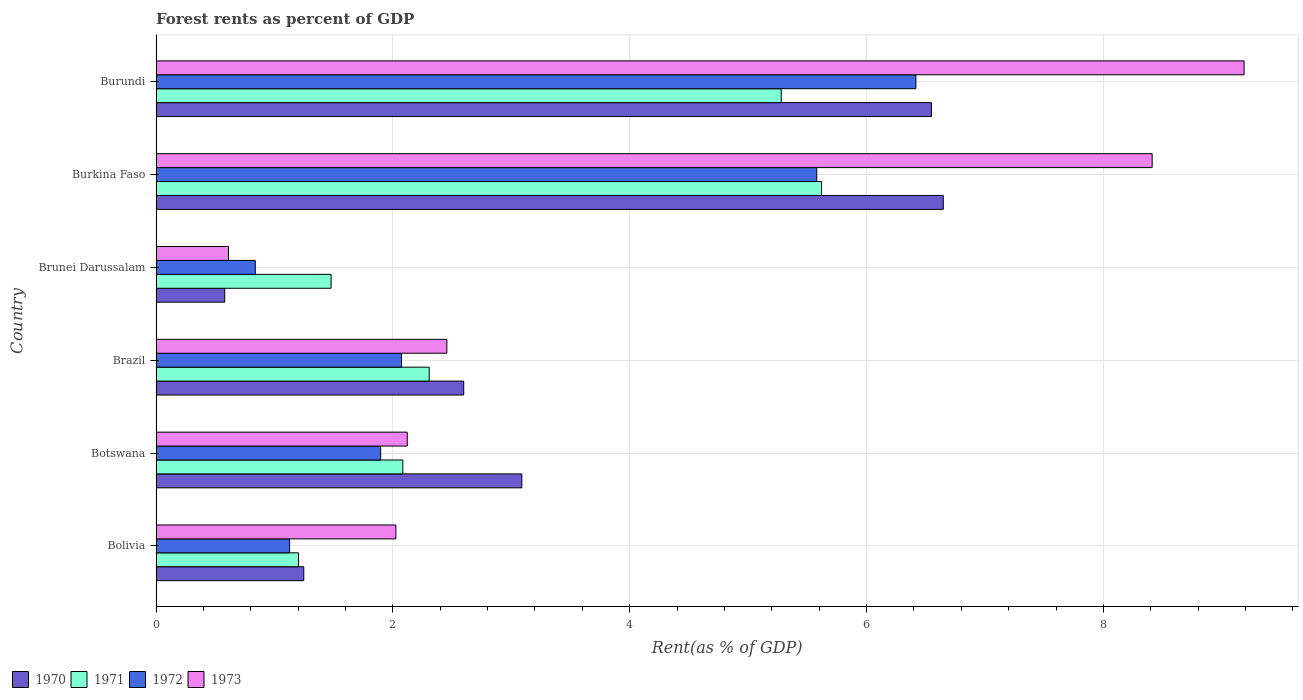Are the number of bars per tick equal to the number of legend labels?
Keep it short and to the point. Yes. How many bars are there on the 3rd tick from the top?
Provide a succinct answer. 4. How many bars are there on the 3rd tick from the bottom?
Ensure brevity in your answer.  4. What is the label of the 5th group of bars from the top?
Ensure brevity in your answer.  Botswana. What is the forest rent in 1970 in Brunei Darussalam?
Your answer should be compact. 0.58. Across all countries, what is the maximum forest rent in 1970?
Offer a very short reply. 6.65. Across all countries, what is the minimum forest rent in 1973?
Provide a short and direct response. 0.61. In which country was the forest rent in 1970 maximum?
Provide a short and direct response. Burkina Faso. What is the total forest rent in 1972 in the graph?
Offer a very short reply. 17.93. What is the difference between the forest rent in 1973 in Bolivia and that in Burkina Faso?
Provide a succinct answer. -6.39. What is the difference between the forest rent in 1973 in Brunei Darussalam and the forest rent in 1971 in Brazil?
Make the answer very short. -1.7. What is the average forest rent in 1970 per country?
Your answer should be very brief. 3.45. What is the difference between the forest rent in 1971 and forest rent in 1973 in Brazil?
Provide a succinct answer. -0.15. In how many countries, is the forest rent in 1971 greater than 2.4 %?
Give a very brief answer. 2. What is the ratio of the forest rent in 1973 in Botswana to that in Brunei Darussalam?
Offer a terse response. 3.47. What is the difference between the highest and the second highest forest rent in 1971?
Your answer should be very brief. 0.34. What is the difference between the highest and the lowest forest rent in 1972?
Keep it short and to the point. 5.58. Is the sum of the forest rent in 1971 in Burkina Faso and Burundi greater than the maximum forest rent in 1970 across all countries?
Provide a short and direct response. Yes. What does the 3rd bar from the bottom in Botswana represents?
Offer a very short reply. 1972. How many bars are there?
Provide a succinct answer. 24. Are all the bars in the graph horizontal?
Your answer should be compact. Yes. How many countries are there in the graph?
Ensure brevity in your answer.  6. Are the values on the major ticks of X-axis written in scientific E-notation?
Give a very brief answer. No. Does the graph contain any zero values?
Provide a succinct answer. No. Does the graph contain grids?
Provide a succinct answer. Yes. How are the legend labels stacked?
Give a very brief answer. Horizontal. What is the title of the graph?
Keep it short and to the point. Forest rents as percent of GDP. What is the label or title of the X-axis?
Make the answer very short. Rent(as % of GDP). What is the Rent(as % of GDP) of 1970 in Bolivia?
Your answer should be very brief. 1.25. What is the Rent(as % of GDP) of 1971 in Bolivia?
Make the answer very short. 1.2. What is the Rent(as % of GDP) of 1972 in Bolivia?
Provide a short and direct response. 1.13. What is the Rent(as % of GDP) of 1973 in Bolivia?
Offer a very short reply. 2.03. What is the Rent(as % of GDP) in 1970 in Botswana?
Keep it short and to the point. 3.09. What is the Rent(as % of GDP) of 1971 in Botswana?
Make the answer very short. 2.08. What is the Rent(as % of GDP) in 1972 in Botswana?
Provide a short and direct response. 1.9. What is the Rent(as % of GDP) of 1973 in Botswana?
Your answer should be compact. 2.12. What is the Rent(as % of GDP) of 1970 in Brazil?
Ensure brevity in your answer.  2.6. What is the Rent(as % of GDP) in 1971 in Brazil?
Your answer should be compact. 2.31. What is the Rent(as % of GDP) in 1972 in Brazil?
Give a very brief answer. 2.07. What is the Rent(as % of GDP) of 1973 in Brazil?
Give a very brief answer. 2.46. What is the Rent(as % of GDP) in 1970 in Brunei Darussalam?
Your answer should be very brief. 0.58. What is the Rent(as % of GDP) in 1971 in Brunei Darussalam?
Your answer should be compact. 1.48. What is the Rent(as % of GDP) of 1972 in Brunei Darussalam?
Ensure brevity in your answer.  0.84. What is the Rent(as % of GDP) in 1973 in Brunei Darussalam?
Make the answer very short. 0.61. What is the Rent(as % of GDP) in 1970 in Burkina Faso?
Ensure brevity in your answer.  6.65. What is the Rent(as % of GDP) of 1971 in Burkina Faso?
Your answer should be compact. 5.62. What is the Rent(as % of GDP) in 1972 in Burkina Faso?
Keep it short and to the point. 5.58. What is the Rent(as % of GDP) in 1973 in Burkina Faso?
Provide a succinct answer. 8.41. What is the Rent(as % of GDP) in 1970 in Burundi?
Your answer should be compact. 6.55. What is the Rent(as % of GDP) of 1971 in Burundi?
Offer a very short reply. 5.28. What is the Rent(as % of GDP) in 1972 in Burundi?
Ensure brevity in your answer.  6.42. What is the Rent(as % of GDP) in 1973 in Burundi?
Keep it short and to the point. 9.19. Across all countries, what is the maximum Rent(as % of GDP) in 1970?
Ensure brevity in your answer.  6.65. Across all countries, what is the maximum Rent(as % of GDP) of 1971?
Keep it short and to the point. 5.62. Across all countries, what is the maximum Rent(as % of GDP) of 1972?
Ensure brevity in your answer.  6.42. Across all countries, what is the maximum Rent(as % of GDP) in 1973?
Your answer should be compact. 9.19. Across all countries, what is the minimum Rent(as % of GDP) of 1970?
Your answer should be very brief. 0.58. Across all countries, what is the minimum Rent(as % of GDP) in 1971?
Ensure brevity in your answer.  1.2. Across all countries, what is the minimum Rent(as % of GDP) in 1972?
Provide a short and direct response. 0.84. Across all countries, what is the minimum Rent(as % of GDP) of 1973?
Keep it short and to the point. 0.61. What is the total Rent(as % of GDP) in 1970 in the graph?
Keep it short and to the point. 20.71. What is the total Rent(as % of GDP) in 1971 in the graph?
Give a very brief answer. 17.97. What is the total Rent(as % of GDP) in 1972 in the graph?
Provide a succinct answer. 17.93. What is the total Rent(as % of GDP) in 1973 in the graph?
Give a very brief answer. 24.81. What is the difference between the Rent(as % of GDP) of 1970 in Bolivia and that in Botswana?
Your answer should be very brief. -1.84. What is the difference between the Rent(as % of GDP) in 1971 in Bolivia and that in Botswana?
Give a very brief answer. -0.88. What is the difference between the Rent(as % of GDP) of 1972 in Bolivia and that in Botswana?
Make the answer very short. -0.77. What is the difference between the Rent(as % of GDP) in 1973 in Bolivia and that in Botswana?
Provide a short and direct response. -0.1. What is the difference between the Rent(as % of GDP) of 1970 in Bolivia and that in Brazil?
Ensure brevity in your answer.  -1.35. What is the difference between the Rent(as % of GDP) of 1971 in Bolivia and that in Brazil?
Provide a short and direct response. -1.1. What is the difference between the Rent(as % of GDP) in 1972 in Bolivia and that in Brazil?
Offer a terse response. -0.95. What is the difference between the Rent(as % of GDP) of 1973 in Bolivia and that in Brazil?
Provide a succinct answer. -0.43. What is the difference between the Rent(as % of GDP) in 1970 in Bolivia and that in Brunei Darussalam?
Provide a short and direct response. 0.67. What is the difference between the Rent(as % of GDP) in 1971 in Bolivia and that in Brunei Darussalam?
Your answer should be compact. -0.28. What is the difference between the Rent(as % of GDP) in 1972 in Bolivia and that in Brunei Darussalam?
Your answer should be very brief. 0.29. What is the difference between the Rent(as % of GDP) in 1973 in Bolivia and that in Brunei Darussalam?
Offer a terse response. 1.41. What is the difference between the Rent(as % of GDP) of 1970 in Bolivia and that in Burkina Faso?
Provide a short and direct response. -5.4. What is the difference between the Rent(as % of GDP) of 1971 in Bolivia and that in Burkina Faso?
Your response must be concise. -4.42. What is the difference between the Rent(as % of GDP) of 1972 in Bolivia and that in Burkina Faso?
Give a very brief answer. -4.45. What is the difference between the Rent(as % of GDP) of 1973 in Bolivia and that in Burkina Faso?
Provide a succinct answer. -6.39. What is the difference between the Rent(as % of GDP) in 1970 in Bolivia and that in Burundi?
Give a very brief answer. -5.3. What is the difference between the Rent(as % of GDP) in 1971 in Bolivia and that in Burundi?
Offer a terse response. -4.08. What is the difference between the Rent(as % of GDP) of 1972 in Bolivia and that in Burundi?
Your answer should be compact. -5.29. What is the difference between the Rent(as % of GDP) of 1973 in Bolivia and that in Burundi?
Offer a terse response. -7.16. What is the difference between the Rent(as % of GDP) of 1970 in Botswana and that in Brazil?
Offer a terse response. 0.49. What is the difference between the Rent(as % of GDP) of 1971 in Botswana and that in Brazil?
Ensure brevity in your answer.  -0.22. What is the difference between the Rent(as % of GDP) of 1972 in Botswana and that in Brazil?
Provide a short and direct response. -0.18. What is the difference between the Rent(as % of GDP) in 1973 in Botswana and that in Brazil?
Ensure brevity in your answer.  -0.33. What is the difference between the Rent(as % of GDP) in 1970 in Botswana and that in Brunei Darussalam?
Your response must be concise. 2.51. What is the difference between the Rent(as % of GDP) of 1971 in Botswana and that in Brunei Darussalam?
Your answer should be compact. 0.61. What is the difference between the Rent(as % of GDP) of 1972 in Botswana and that in Brunei Darussalam?
Give a very brief answer. 1.06. What is the difference between the Rent(as % of GDP) of 1973 in Botswana and that in Brunei Darussalam?
Ensure brevity in your answer.  1.51. What is the difference between the Rent(as % of GDP) of 1970 in Botswana and that in Burkina Faso?
Your answer should be very brief. -3.56. What is the difference between the Rent(as % of GDP) in 1971 in Botswana and that in Burkina Faso?
Ensure brevity in your answer.  -3.54. What is the difference between the Rent(as % of GDP) in 1972 in Botswana and that in Burkina Faso?
Offer a very short reply. -3.68. What is the difference between the Rent(as % of GDP) in 1973 in Botswana and that in Burkina Faso?
Keep it short and to the point. -6.29. What is the difference between the Rent(as % of GDP) of 1970 in Botswana and that in Burundi?
Keep it short and to the point. -3.46. What is the difference between the Rent(as % of GDP) of 1971 in Botswana and that in Burundi?
Your response must be concise. -3.2. What is the difference between the Rent(as % of GDP) in 1972 in Botswana and that in Burundi?
Provide a short and direct response. -4.52. What is the difference between the Rent(as % of GDP) of 1973 in Botswana and that in Burundi?
Make the answer very short. -7.07. What is the difference between the Rent(as % of GDP) in 1970 in Brazil and that in Brunei Darussalam?
Keep it short and to the point. 2.02. What is the difference between the Rent(as % of GDP) of 1971 in Brazil and that in Brunei Darussalam?
Offer a terse response. 0.83. What is the difference between the Rent(as % of GDP) of 1972 in Brazil and that in Brunei Darussalam?
Your answer should be very brief. 1.24. What is the difference between the Rent(as % of GDP) of 1973 in Brazil and that in Brunei Darussalam?
Your answer should be very brief. 1.84. What is the difference between the Rent(as % of GDP) of 1970 in Brazil and that in Burkina Faso?
Offer a very short reply. -4.05. What is the difference between the Rent(as % of GDP) of 1971 in Brazil and that in Burkina Faso?
Ensure brevity in your answer.  -3.31. What is the difference between the Rent(as % of GDP) in 1972 in Brazil and that in Burkina Faso?
Provide a short and direct response. -3.51. What is the difference between the Rent(as % of GDP) in 1973 in Brazil and that in Burkina Faso?
Provide a short and direct response. -5.96. What is the difference between the Rent(as % of GDP) of 1970 in Brazil and that in Burundi?
Provide a succinct answer. -3.95. What is the difference between the Rent(as % of GDP) of 1971 in Brazil and that in Burundi?
Provide a succinct answer. -2.97. What is the difference between the Rent(as % of GDP) in 1972 in Brazil and that in Burundi?
Offer a terse response. -4.34. What is the difference between the Rent(as % of GDP) of 1973 in Brazil and that in Burundi?
Your answer should be compact. -6.73. What is the difference between the Rent(as % of GDP) in 1970 in Brunei Darussalam and that in Burkina Faso?
Your answer should be very brief. -6.07. What is the difference between the Rent(as % of GDP) in 1971 in Brunei Darussalam and that in Burkina Faso?
Make the answer very short. -4.14. What is the difference between the Rent(as % of GDP) in 1972 in Brunei Darussalam and that in Burkina Faso?
Offer a very short reply. -4.74. What is the difference between the Rent(as % of GDP) in 1973 in Brunei Darussalam and that in Burkina Faso?
Your answer should be very brief. -7.8. What is the difference between the Rent(as % of GDP) in 1970 in Brunei Darussalam and that in Burundi?
Ensure brevity in your answer.  -5.97. What is the difference between the Rent(as % of GDP) in 1971 in Brunei Darussalam and that in Burundi?
Provide a short and direct response. -3.8. What is the difference between the Rent(as % of GDP) of 1972 in Brunei Darussalam and that in Burundi?
Your answer should be compact. -5.58. What is the difference between the Rent(as % of GDP) of 1973 in Brunei Darussalam and that in Burundi?
Make the answer very short. -8.58. What is the difference between the Rent(as % of GDP) of 1970 in Burkina Faso and that in Burundi?
Provide a short and direct response. 0.1. What is the difference between the Rent(as % of GDP) in 1971 in Burkina Faso and that in Burundi?
Your answer should be compact. 0.34. What is the difference between the Rent(as % of GDP) in 1972 in Burkina Faso and that in Burundi?
Offer a terse response. -0.84. What is the difference between the Rent(as % of GDP) of 1973 in Burkina Faso and that in Burundi?
Give a very brief answer. -0.78. What is the difference between the Rent(as % of GDP) of 1970 in Bolivia and the Rent(as % of GDP) of 1971 in Botswana?
Your answer should be compact. -0.84. What is the difference between the Rent(as % of GDP) of 1970 in Bolivia and the Rent(as % of GDP) of 1972 in Botswana?
Provide a succinct answer. -0.65. What is the difference between the Rent(as % of GDP) of 1970 in Bolivia and the Rent(as % of GDP) of 1973 in Botswana?
Make the answer very short. -0.87. What is the difference between the Rent(as % of GDP) in 1971 in Bolivia and the Rent(as % of GDP) in 1972 in Botswana?
Make the answer very short. -0.69. What is the difference between the Rent(as % of GDP) in 1971 in Bolivia and the Rent(as % of GDP) in 1973 in Botswana?
Your answer should be very brief. -0.92. What is the difference between the Rent(as % of GDP) in 1972 in Bolivia and the Rent(as % of GDP) in 1973 in Botswana?
Provide a short and direct response. -0.99. What is the difference between the Rent(as % of GDP) of 1970 in Bolivia and the Rent(as % of GDP) of 1971 in Brazil?
Give a very brief answer. -1.06. What is the difference between the Rent(as % of GDP) of 1970 in Bolivia and the Rent(as % of GDP) of 1972 in Brazil?
Give a very brief answer. -0.83. What is the difference between the Rent(as % of GDP) in 1970 in Bolivia and the Rent(as % of GDP) in 1973 in Brazil?
Ensure brevity in your answer.  -1.21. What is the difference between the Rent(as % of GDP) of 1971 in Bolivia and the Rent(as % of GDP) of 1972 in Brazil?
Keep it short and to the point. -0.87. What is the difference between the Rent(as % of GDP) of 1971 in Bolivia and the Rent(as % of GDP) of 1973 in Brazil?
Offer a very short reply. -1.25. What is the difference between the Rent(as % of GDP) in 1972 in Bolivia and the Rent(as % of GDP) in 1973 in Brazil?
Offer a very short reply. -1.33. What is the difference between the Rent(as % of GDP) of 1970 in Bolivia and the Rent(as % of GDP) of 1971 in Brunei Darussalam?
Make the answer very short. -0.23. What is the difference between the Rent(as % of GDP) of 1970 in Bolivia and the Rent(as % of GDP) of 1972 in Brunei Darussalam?
Offer a very short reply. 0.41. What is the difference between the Rent(as % of GDP) in 1970 in Bolivia and the Rent(as % of GDP) in 1973 in Brunei Darussalam?
Your answer should be very brief. 0.64. What is the difference between the Rent(as % of GDP) in 1971 in Bolivia and the Rent(as % of GDP) in 1972 in Brunei Darussalam?
Keep it short and to the point. 0.36. What is the difference between the Rent(as % of GDP) in 1971 in Bolivia and the Rent(as % of GDP) in 1973 in Brunei Darussalam?
Ensure brevity in your answer.  0.59. What is the difference between the Rent(as % of GDP) in 1972 in Bolivia and the Rent(as % of GDP) in 1973 in Brunei Darussalam?
Provide a succinct answer. 0.52. What is the difference between the Rent(as % of GDP) of 1970 in Bolivia and the Rent(as % of GDP) of 1971 in Burkina Faso?
Give a very brief answer. -4.37. What is the difference between the Rent(as % of GDP) of 1970 in Bolivia and the Rent(as % of GDP) of 1972 in Burkina Faso?
Provide a succinct answer. -4.33. What is the difference between the Rent(as % of GDP) in 1970 in Bolivia and the Rent(as % of GDP) in 1973 in Burkina Faso?
Your answer should be very brief. -7.16. What is the difference between the Rent(as % of GDP) in 1971 in Bolivia and the Rent(as % of GDP) in 1972 in Burkina Faso?
Keep it short and to the point. -4.38. What is the difference between the Rent(as % of GDP) of 1971 in Bolivia and the Rent(as % of GDP) of 1973 in Burkina Faso?
Your answer should be very brief. -7.21. What is the difference between the Rent(as % of GDP) of 1972 in Bolivia and the Rent(as % of GDP) of 1973 in Burkina Faso?
Provide a succinct answer. -7.28. What is the difference between the Rent(as % of GDP) of 1970 in Bolivia and the Rent(as % of GDP) of 1971 in Burundi?
Your response must be concise. -4.03. What is the difference between the Rent(as % of GDP) in 1970 in Bolivia and the Rent(as % of GDP) in 1972 in Burundi?
Ensure brevity in your answer.  -5.17. What is the difference between the Rent(as % of GDP) in 1970 in Bolivia and the Rent(as % of GDP) in 1973 in Burundi?
Provide a short and direct response. -7.94. What is the difference between the Rent(as % of GDP) in 1971 in Bolivia and the Rent(as % of GDP) in 1972 in Burundi?
Offer a terse response. -5.21. What is the difference between the Rent(as % of GDP) in 1971 in Bolivia and the Rent(as % of GDP) in 1973 in Burundi?
Keep it short and to the point. -7.99. What is the difference between the Rent(as % of GDP) of 1972 in Bolivia and the Rent(as % of GDP) of 1973 in Burundi?
Your answer should be compact. -8.06. What is the difference between the Rent(as % of GDP) in 1970 in Botswana and the Rent(as % of GDP) in 1971 in Brazil?
Provide a succinct answer. 0.78. What is the difference between the Rent(as % of GDP) in 1970 in Botswana and the Rent(as % of GDP) in 1972 in Brazil?
Make the answer very short. 1.02. What is the difference between the Rent(as % of GDP) of 1970 in Botswana and the Rent(as % of GDP) of 1973 in Brazil?
Your answer should be very brief. 0.63. What is the difference between the Rent(as % of GDP) in 1971 in Botswana and the Rent(as % of GDP) in 1972 in Brazil?
Offer a very short reply. 0.01. What is the difference between the Rent(as % of GDP) of 1971 in Botswana and the Rent(as % of GDP) of 1973 in Brazil?
Your response must be concise. -0.37. What is the difference between the Rent(as % of GDP) in 1972 in Botswana and the Rent(as % of GDP) in 1973 in Brazil?
Offer a very short reply. -0.56. What is the difference between the Rent(as % of GDP) in 1970 in Botswana and the Rent(as % of GDP) in 1971 in Brunei Darussalam?
Offer a very short reply. 1.61. What is the difference between the Rent(as % of GDP) of 1970 in Botswana and the Rent(as % of GDP) of 1972 in Brunei Darussalam?
Give a very brief answer. 2.25. What is the difference between the Rent(as % of GDP) in 1970 in Botswana and the Rent(as % of GDP) in 1973 in Brunei Darussalam?
Ensure brevity in your answer.  2.48. What is the difference between the Rent(as % of GDP) of 1971 in Botswana and the Rent(as % of GDP) of 1972 in Brunei Darussalam?
Provide a succinct answer. 1.25. What is the difference between the Rent(as % of GDP) in 1971 in Botswana and the Rent(as % of GDP) in 1973 in Brunei Darussalam?
Offer a terse response. 1.47. What is the difference between the Rent(as % of GDP) in 1972 in Botswana and the Rent(as % of GDP) in 1973 in Brunei Darussalam?
Your answer should be very brief. 1.29. What is the difference between the Rent(as % of GDP) of 1970 in Botswana and the Rent(as % of GDP) of 1971 in Burkina Faso?
Provide a succinct answer. -2.53. What is the difference between the Rent(as % of GDP) in 1970 in Botswana and the Rent(as % of GDP) in 1972 in Burkina Faso?
Provide a short and direct response. -2.49. What is the difference between the Rent(as % of GDP) in 1970 in Botswana and the Rent(as % of GDP) in 1973 in Burkina Faso?
Ensure brevity in your answer.  -5.32. What is the difference between the Rent(as % of GDP) of 1971 in Botswana and the Rent(as % of GDP) of 1972 in Burkina Faso?
Your answer should be compact. -3.5. What is the difference between the Rent(as % of GDP) in 1971 in Botswana and the Rent(as % of GDP) in 1973 in Burkina Faso?
Ensure brevity in your answer.  -6.33. What is the difference between the Rent(as % of GDP) in 1972 in Botswana and the Rent(as % of GDP) in 1973 in Burkina Faso?
Your answer should be very brief. -6.51. What is the difference between the Rent(as % of GDP) in 1970 in Botswana and the Rent(as % of GDP) in 1971 in Burundi?
Ensure brevity in your answer.  -2.19. What is the difference between the Rent(as % of GDP) of 1970 in Botswana and the Rent(as % of GDP) of 1972 in Burundi?
Offer a terse response. -3.33. What is the difference between the Rent(as % of GDP) in 1970 in Botswana and the Rent(as % of GDP) in 1973 in Burundi?
Offer a terse response. -6.1. What is the difference between the Rent(as % of GDP) in 1971 in Botswana and the Rent(as % of GDP) in 1972 in Burundi?
Ensure brevity in your answer.  -4.33. What is the difference between the Rent(as % of GDP) of 1971 in Botswana and the Rent(as % of GDP) of 1973 in Burundi?
Your answer should be compact. -7.1. What is the difference between the Rent(as % of GDP) in 1972 in Botswana and the Rent(as % of GDP) in 1973 in Burundi?
Your answer should be very brief. -7.29. What is the difference between the Rent(as % of GDP) of 1970 in Brazil and the Rent(as % of GDP) of 1971 in Brunei Darussalam?
Offer a terse response. 1.12. What is the difference between the Rent(as % of GDP) in 1970 in Brazil and the Rent(as % of GDP) in 1972 in Brunei Darussalam?
Make the answer very short. 1.76. What is the difference between the Rent(as % of GDP) in 1970 in Brazil and the Rent(as % of GDP) in 1973 in Brunei Darussalam?
Keep it short and to the point. 1.99. What is the difference between the Rent(as % of GDP) in 1971 in Brazil and the Rent(as % of GDP) in 1972 in Brunei Darussalam?
Your response must be concise. 1.47. What is the difference between the Rent(as % of GDP) of 1971 in Brazil and the Rent(as % of GDP) of 1973 in Brunei Darussalam?
Your response must be concise. 1.7. What is the difference between the Rent(as % of GDP) of 1972 in Brazil and the Rent(as % of GDP) of 1973 in Brunei Darussalam?
Your response must be concise. 1.46. What is the difference between the Rent(as % of GDP) in 1970 in Brazil and the Rent(as % of GDP) in 1971 in Burkina Faso?
Your response must be concise. -3.02. What is the difference between the Rent(as % of GDP) in 1970 in Brazil and the Rent(as % of GDP) in 1972 in Burkina Faso?
Your response must be concise. -2.98. What is the difference between the Rent(as % of GDP) of 1970 in Brazil and the Rent(as % of GDP) of 1973 in Burkina Faso?
Give a very brief answer. -5.81. What is the difference between the Rent(as % of GDP) of 1971 in Brazil and the Rent(as % of GDP) of 1972 in Burkina Faso?
Ensure brevity in your answer.  -3.27. What is the difference between the Rent(as % of GDP) of 1971 in Brazil and the Rent(as % of GDP) of 1973 in Burkina Faso?
Your answer should be compact. -6.11. What is the difference between the Rent(as % of GDP) of 1972 in Brazil and the Rent(as % of GDP) of 1973 in Burkina Faso?
Your answer should be very brief. -6.34. What is the difference between the Rent(as % of GDP) in 1970 in Brazil and the Rent(as % of GDP) in 1971 in Burundi?
Give a very brief answer. -2.68. What is the difference between the Rent(as % of GDP) of 1970 in Brazil and the Rent(as % of GDP) of 1972 in Burundi?
Give a very brief answer. -3.82. What is the difference between the Rent(as % of GDP) of 1970 in Brazil and the Rent(as % of GDP) of 1973 in Burundi?
Give a very brief answer. -6.59. What is the difference between the Rent(as % of GDP) of 1971 in Brazil and the Rent(as % of GDP) of 1972 in Burundi?
Offer a very short reply. -4.11. What is the difference between the Rent(as % of GDP) of 1971 in Brazil and the Rent(as % of GDP) of 1973 in Burundi?
Provide a short and direct response. -6.88. What is the difference between the Rent(as % of GDP) in 1972 in Brazil and the Rent(as % of GDP) in 1973 in Burundi?
Keep it short and to the point. -7.11. What is the difference between the Rent(as % of GDP) of 1970 in Brunei Darussalam and the Rent(as % of GDP) of 1971 in Burkina Faso?
Give a very brief answer. -5.04. What is the difference between the Rent(as % of GDP) in 1970 in Brunei Darussalam and the Rent(as % of GDP) in 1972 in Burkina Faso?
Keep it short and to the point. -5. What is the difference between the Rent(as % of GDP) in 1970 in Brunei Darussalam and the Rent(as % of GDP) in 1973 in Burkina Faso?
Offer a very short reply. -7.83. What is the difference between the Rent(as % of GDP) in 1971 in Brunei Darussalam and the Rent(as % of GDP) in 1972 in Burkina Faso?
Ensure brevity in your answer.  -4.1. What is the difference between the Rent(as % of GDP) in 1971 in Brunei Darussalam and the Rent(as % of GDP) in 1973 in Burkina Faso?
Your response must be concise. -6.93. What is the difference between the Rent(as % of GDP) in 1972 in Brunei Darussalam and the Rent(as % of GDP) in 1973 in Burkina Faso?
Offer a terse response. -7.57. What is the difference between the Rent(as % of GDP) in 1970 in Brunei Darussalam and the Rent(as % of GDP) in 1971 in Burundi?
Your answer should be compact. -4.7. What is the difference between the Rent(as % of GDP) in 1970 in Brunei Darussalam and the Rent(as % of GDP) in 1972 in Burundi?
Offer a very short reply. -5.84. What is the difference between the Rent(as % of GDP) of 1970 in Brunei Darussalam and the Rent(as % of GDP) of 1973 in Burundi?
Your response must be concise. -8.61. What is the difference between the Rent(as % of GDP) of 1971 in Brunei Darussalam and the Rent(as % of GDP) of 1972 in Burundi?
Offer a very short reply. -4.94. What is the difference between the Rent(as % of GDP) of 1971 in Brunei Darussalam and the Rent(as % of GDP) of 1973 in Burundi?
Provide a short and direct response. -7.71. What is the difference between the Rent(as % of GDP) of 1972 in Brunei Darussalam and the Rent(as % of GDP) of 1973 in Burundi?
Keep it short and to the point. -8.35. What is the difference between the Rent(as % of GDP) in 1970 in Burkina Faso and the Rent(as % of GDP) in 1971 in Burundi?
Make the answer very short. 1.37. What is the difference between the Rent(as % of GDP) in 1970 in Burkina Faso and the Rent(as % of GDP) in 1972 in Burundi?
Offer a terse response. 0.23. What is the difference between the Rent(as % of GDP) of 1970 in Burkina Faso and the Rent(as % of GDP) of 1973 in Burundi?
Your response must be concise. -2.54. What is the difference between the Rent(as % of GDP) of 1971 in Burkina Faso and the Rent(as % of GDP) of 1972 in Burundi?
Make the answer very short. -0.8. What is the difference between the Rent(as % of GDP) of 1971 in Burkina Faso and the Rent(as % of GDP) of 1973 in Burundi?
Keep it short and to the point. -3.57. What is the difference between the Rent(as % of GDP) of 1972 in Burkina Faso and the Rent(as % of GDP) of 1973 in Burundi?
Give a very brief answer. -3.61. What is the average Rent(as % of GDP) of 1970 per country?
Give a very brief answer. 3.45. What is the average Rent(as % of GDP) of 1971 per country?
Offer a terse response. 3. What is the average Rent(as % of GDP) in 1972 per country?
Keep it short and to the point. 2.99. What is the average Rent(as % of GDP) in 1973 per country?
Keep it short and to the point. 4.14. What is the difference between the Rent(as % of GDP) of 1970 and Rent(as % of GDP) of 1971 in Bolivia?
Your answer should be very brief. 0.04. What is the difference between the Rent(as % of GDP) of 1970 and Rent(as % of GDP) of 1972 in Bolivia?
Your response must be concise. 0.12. What is the difference between the Rent(as % of GDP) in 1970 and Rent(as % of GDP) in 1973 in Bolivia?
Provide a short and direct response. -0.78. What is the difference between the Rent(as % of GDP) in 1971 and Rent(as % of GDP) in 1972 in Bolivia?
Offer a terse response. 0.08. What is the difference between the Rent(as % of GDP) of 1971 and Rent(as % of GDP) of 1973 in Bolivia?
Keep it short and to the point. -0.82. What is the difference between the Rent(as % of GDP) in 1972 and Rent(as % of GDP) in 1973 in Bolivia?
Your answer should be compact. -0.9. What is the difference between the Rent(as % of GDP) in 1970 and Rent(as % of GDP) in 1972 in Botswana?
Keep it short and to the point. 1.19. What is the difference between the Rent(as % of GDP) in 1970 and Rent(as % of GDP) in 1973 in Botswana?
Make the answer very short. 0.97. What is the difference between the Rent(as % of GDP) of 1971 and Rent(as % of GDP) of 1972 in Botswana?
Ensure brevity in your answer.  0.19. What is the difference between the Rent(as % of GDP) in 1971 and Rent(as % of GDP) in 1973 in Botswana?
Your response must be concise. -0.04. What is the difference between the Rent(as % of GDP) in 1972 and Rent(as % of GDP) in 1973 in Botswana?
Give a very brief answer. -0.22. What is the difference between the Rent(as % of GDP) of 1970 and Rent(as % of GDP) of 1971 in Brazil?
Your answer should be compact. 0.29. What is the difference between the Rent(as % of GDP) in 1970 and Rent(as % of GDP) in 1972 in Brazil?
Ensure brevity in your answer.  0.52. What is the difference between the Rent(as % of GDP) in 1970 and Rent(as % of GDP) in 1973 in Brazil?
Provide a short and direct response. 0.14. What is the difference between the Rent(as % of GDP) in 1971 and Rent(as % of GDP) in 1972 in Brazil?
Keep it short and to the point. 0.23. What is the difference between the Rent(as % of GDP) of 1971 and Rent(as % of GDP) of 1973 in Brazil?
Your answer should be compact. -0.15. What is the difference between the Rent(as % of GDP) of 1972 and Rent(as % of GDP) of 1973 in Brazil?
Make the answer very short. -0.38. What is the difference between the Rent(as % of GDP) in 1970 and Rent(as % of GDP) in 1971 in Brunei Darussalam?
Your answer should be very brief. -0.9. What is the difference between the Rent(as % of GDP) in 1970 and Rent(as % of GDP) in 1972 in Brunei Darussalam?
Your answer should be compact. -0.26. What is the difference between the Rent(as % of GDP) in 1970 and Rent(as % of GDP) in 1973 in Brunei Darussalam?
Your answer should be compact. -0.03. What is the difference between the Rent(as % of GDP) of 1971 and Rent(as % of GDP) of 1972 in Brunei Darussalam?
Keep it short and to the point. 0.64. What is the difference between the Rent(as % of GDP) in 1971 and Rent(as % of GDP) in 1973 in Brunei Darussalam?
Ensure brevity in your answer.  0.87. What is the difference between the Rent(as % of GDP) of 1972 and Rent(as % of GDP) of 1973 in Brunei Darussalam?
Offer a terse response. 0.23. What is the difference between the Rent(as % of GDP) of 1970 and Rent(as % of GDP) of 1971 in Burkina Faso?
Your response must be concise. 1.03. What is the difference between the Rent(as % of GDP) in 1970 and Rent(as % of GDP) in 1972 in Burkina Faso?
Offer a very short reply. 1.07. What is the difference between the Rent(as % of GDP) of 1970 and Rent(as % of GDP) of 1973 in Burkina Faso?
Your answer should be compact. -1.76. What is the difference between the Rent(as % of GDP) in 1971 and Rent(as % of GDP) in 1972 in Burkina Faso?
Offer a terse response. 0.04. What is the difference between the Rent(as % of GDP) of 1971 and Rent(as % of GDP) of 1973 in Burkina Faso?
Your answer should be very brief. -2.79. What is the difference between the Rent(as % of GDP) in 1972 and Rent(as % of GDP) in 1973 in Burkina Faso?
Provide a succinct answer. -2.83. What is the difference between the Rent(as % of GDP) of 1970 and Rent(as % of GDP) of 1971 in Burundi?
Give a very brief answer. 1.27. What is the difference between the Rent(as % of GDP) in 1970 and Rent(as % of GDP) in 1972 in Burundi?
Your answer should be compact. 0.13. What is the difference between the Rent(as % of GDP) of 1970 and Rent(as % of GDP) of 1973 in Burundi?
Offer a very short reply. -2.64. What is the difference between the Rent(as % of GDP) of 1971 and Rent(as % of GDP) of 1972 in Burundi?
Keep it short and to the point. -1.14. What is the difference between the Rent(as % of GDP) in 1971 and Rent(as % of GDP) in 1973 in Burundi?
Keep it short and to the point. -3.91. What is the difference between the Rent(as % of GDP) of 1972 and Rent(as % of GDP) of 1973 in Burundi?
Your response must be concise. -2.77. What is the ratio of the Rent(as % of GDP) of 1970 in Bolivia to that in Botswana?
Offer a very short reply. 0.4. What is the ratio of the Rent(as % of GDP) in 1971 in Bolivia to that in Botswana?
Keep it short and to the point. 0.58. What is the ratio of the Rent(as % of GDP) in 1972 in Bolivia to that in Botswana?
Keep it short and to the point. 0.59. What is the ratio of the Rent(as % of GDP) of 1973 in Bolivia to that in Botswana?
Make the answer very short. 0.95. What is the ratio of the Rent(as % of GDP) of 1970 in Bolivia to that in Brazil?
Your answer should be very brief. 0.48. What is the ratio of the Rent(as % of GDP) in 1971 in Bolivia to that in Brazil?
Offer a terse response. 0.52. What is the ratio of the Rent(as % of GDP) of 1972 in Bolivia to that in Brazil?
Offer a terse response. 0.54. What is the ratio of the Rent(as % of GDP) of 1973 in Bolivia to that in Brazil?
Your response must be concise. 0.82. What is the ratio of the Rent(as % of GDP) of 1970 in Bolivia to that in Brunei Darussalam?
Ensure brevity in your answer.  2.15. What is the ratio of the Rent(as % of GDP) of 1971 in Bolivia to that in Brunei Darussalam?
Offer a very short reply. 0.81. What is the ratio of the Rent(as % of GDP) of 1972 in Bolivia to that in Brunei Darussalam?
Provide a succinct answer. 1.35. What is the ratio of the Rent(as % of GDP) of 1973 in Bolivia to that in Brunei Darussalam?
Provide a short and direct response. 3.31. What is the ratio of the Rent(as % of GDP) in 1970 in Bolivia to that in Burkina Faso?
Provide a short and direct response. 0.19. What is the ratio of the Rent(as % of GDP) of 1971 in Bolivia to that in Burkina Faso?
Provide a succinct answer. 0.21. What is the ratio of the Rent(as % of GDP) in 1972 in Bolivia to that in Burkina Faso?
Ensure brevity in your answer.  0.2. What is the ratio of the Rent(as % of GDP) of 1973 in Bolivia to that in Burkina Faso?
Give a very brief answer. 0.24. What is the ratio of the Rent(as % of GDP) in 1970 in Bolivia to that in Burundi?
Offer a terse response. 0.19. What is the ratio of the Rent(as % of GDP) in 1971 in Bolivia to that in Burundi?
Keep it short and to the point. 0.23. What is the ratio of the Rent(as % of GDP) of 1972 in Bolivia to that in Burundi?
Offer a terse response. 0.18. What is the ratio of the Rent(as % of GDP) in 1973 in Bolivia to that in Burundi?
Keep it short and to the point. 0.22. What is the ratio of the Rent(as % of GDP) in 1970 in Botswana to that in Brazil?
Make the answer very short. 1.19. What is the ratio of the Rent(as % of GDP) in 1971 in Botswana to that in Brazil?
Give a very brief answer. 0.9. What is the ratio of the Rent(as % of GDP) of 1972 in Botswana to that in Brazil?
Ensure brevity in your answer.  0.92. What is the ratio of the Rent(as % of GDP) of 1973 in Botswana to that in Brazil?
Your response must be concise. 0.86. What is the ratio of the Rent(as % of GDP) in 1970 in Botswana to that in Brunei Darussalam?
Your answer should be very brief. 5.32. What is the ratio of the Rent(as % of GDP) in 1971 in Botswana to that in Brunei Darussalam?
Keep it short and to the point. 1.41. What is the ratio of the Rent(as % of GDP) in 1972 in Botswana to that in Brunei Darussalam?
Provide a succinct answer. 2.26. What is the ratio of the Rent(as % of GDP) in 1973 in Botswana to that in Brunei Darussalam?
Offer a very short reply. 3.47. What is the ratio of the Rent(as % of GDP) of 1970 in Botswana to that in Burkina Faso?
Ensure brevity in your answer.  0.46. What is the ratio of the Rent(as % of GDP) of 1971 in Botswana to that in Burkina Faso?
Ensure brevity in your answer.  0.37. What is the ratio of the Rent(as % of GDP) in 1972 in Botswana to that in Burkina Faso?
Provide a short and direct response. 0.34. What is the ratio of the Rent(as % of GDP) in 1973 in Botswana to that in Burkina Faso?
Give a very brief answer. 0.25. What is the ratio of the Rent(as % of GDP) in 1970 in Botswana to that in Burundi?
Offer a terse response. 0.47. What is the ratio of the Rent(as % of GDP) in 1971 in Botswana to that in Burundi?
Your response must be concise. 0.39. What is the ratio of the Rent(as % of GDP) of 1972 in Botswana to that in Burundi?
Your response must be concise. 0.3. What is the ratio of the Rent(as % of GDP) of 1973 in Botswana to that in Burundi?
Your answer should be very brief. 0.23. What is the ratio of the Rent(as % of GDP) of 1970 in Brazil to that in Brunei Darussalam?
Provide a succinct answer. 4.48. What is the ratio of the Rent(as % of GDP) in 1971 in Brazil to that in Brunei Darussalam?
Your response must be concise. 1.56. What is the ratio of the Rent(as % of GDP) in 1972 in Brazil to that in Brunei Darussalam?
Offer a very short reply. 2.47. What is the ratio of the Rent(as % of GDP) of 1973 in Brazil to that in Brunei Darussalam?
Offer a terse response. 4.01. What is the ratio of the Rent(as % of GDP) in 1970 in Brazil to that in Burkina Faso?
Provide a short and direct response. 0.39. What is the ratio of the Rent(as % of GDP) of 1971 in Brazil to that in Burkina Faso?
Provide a succinct answer. 0.41. What is the ratio of the Rent(as % of GDP) of 1972 in Brazil to that in Burkina Faso?
Ensure brevity in your answer.  0.37. What is the ratio of the Rent(as % of GDP) in 1973 in Brazil to that in Burkina Faso?
Ensure brevity in your answer.  0.29. What is the ratio of the Rent(as % of GDP) in 1970 in Brazil to that in Burundi?
Your response must be concise. 0.4. What is the ratio of the Rent(as % of GDP) in 1971 in Brazil to that in Burundi?
Provide a short and direct response. 0.44. What is the ratio of the Rent(as % of GDP) of 1972 in Brazil to that in Burundi?
Your answer should be compact. 0.32. What is the ratio of the Rent(as % of GDP) of 1973 in Brazil to that in Burundi?
Offer a very short reply. 0.27. What is the ratio of the Rent(as % of GDP) of 1970 in Brunei Darussalam to that in Burkina Faso?
Your response must be concise. 0.09. What is the ratio of the Rent(as % of GDP) of 1971 in Brunei Darussalam to that in Burkina Faso?
Make the answer very short. 0.26. What is the ratio of the Rent(as % of GDP) of 1972 in Brunei Darussalam to that in Burkina Faso?
Your response must be concise. 0.15. What is the ratio of the Rent(as % of GDP) in 1973 in Brunei Darussalam to that in Burkina Faso?
Provide a succinct answer. 0.07. What is the ratio of the Rent(as % of GDP) in 1970 in Brunei Darussalam to that in Burundi?
Your answer should be compact. 0.09. What is the ratio of the Rent(as % of GDP) of 1971 in Brunei Darussalam to that in Burundi?
Your answer should be very brief. 0.28. What is the ratio of the Rent(as % of GDP) in 1972 in Brunei Darussalam to that in Burundi?
Your answer should be compact. 0.13. What is the ratio of the Rent(as % of GDP) in 1973 in Brunei Darussalam to that in Burundi?
Give a very brief answer. 0.07. What is the ratio of the Rent(as % of GDP) of 1970 in Burkina Faso to that in Burundi?
Keep it short and to the point. 1.02. What is the ratio of the Rent(as % of GDP) in 1971 in Burkina Faso to that in Burundi?
Keep it short and to the point. 1.06. What is the ratio of the Rent(as % of GDP) in 1972 in Burkina Faso to that in Burundi?
Your response must be concise. 0.87. What is the ratio of the Rent(as % of GDP) in 1973 in Burkina Faso to that in Burundi?
Keep it short and to the point. 0.92. What is the difference between the highest and the second highest Rent(as % of GDP) in 1970?
Your answer should be very brief. 0.1. What is the difference between the highest and the second highest Rent(as % of GDP) in 1971?
Your answer should be very brief. 0.34. What is the difference between the highest and the second highest Rent(as % of GDP) in 1972?
Offer a terse response. 0.84. What is the difference between the highest and the second highest Rent(as % of GDP) of 1973?
Your answer should be compact. 0.78. What is the difference between the highest and the lowest Rent(as % of GDP) in 1970?
Ensure brevity in your answer.  6.07. What is the difference between the highest and the lowest Rent(as % of GDP) of 1971?
Your response must be concise. 4.42. What is the difference between the highest and the lowest Rent(as % of GDP) of 1972?
Ensure brevity in your answer.  5.58. What is the difference between the highest and the lowest Rent(as % of GDP) of 1973?
Make the answer very short. 8.58. 